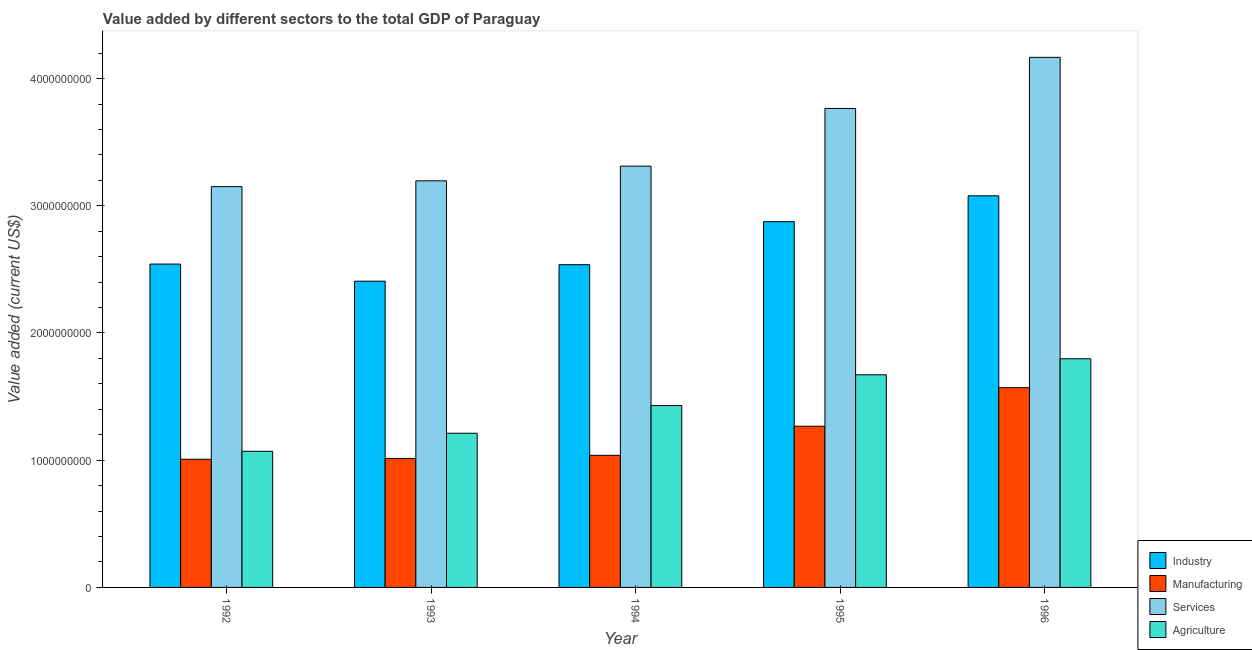How many different coloured bars are there?
Your answer should be compact. 4. How many groups of bars are there?
Make the answer very short. 5. Are the number of bars on each tick of the X-axis equal?
Give a very brief answer. Yes. How many bars are there on the 2nd tick from the left?
Make the answer very short. 4. How many bars are there on the 3rd tick from the right?
Keep it short and to the point. 4. What is the label of the 5th group of bars from the left?
Provide a short and direct response. 1996. What is the value added by services sector in 1995?
Make the answer very short. 3.77e+09. Across all years, what is the maximum value added by manufacturing sector?
Provide a succinct answer. 1.57e+09. Across all years, what is the minimum value added by services sector?
Offer a very short reply. 3.15e+09. In which year was the value added by industrial sector maximum?
Give a very brief answer. 1996. What is the total value added by services sector in the graph?
Offer a terse response. 1.76e+1. What is the difference between the value added by industrial sector in 1993 and that in 1996?
Offer a very short reply. -6.71e+08. What is the difference between the value added by agricultural sector in 1992 and the value added by services sector in 1996?
Ensure brevity in your answer.  -7.28e+08. What is the average value added by services sector per year?
Make the answer very short. 3.52e+09. In how many years, is the value added by manufacturing sector greater than 3000000000 US$?
Provide a short and direct response. 0. What is the ratio of the value added by services sector in 1994 to that in 1995?
Keep it short and to the point. 0.88. Is the difference between the value added by manufacturing sector in 1993 and 1994 greater than the difference between the value added by services sector in 1993 and 1994?
Make the answer very short. No. What is the difference between the highest and the second highest value added by industrial sector?
Your answer should be very brief. 2.03e+08. What is the difference between the highest and the lowest value added by manufacturing sector?
Your answer should be very brief. 5.63e+08. Is it the case that in every year, the sum of the value added by services sector and value added by agricultural sector is greater than the sum of value added by manufacturing sector and value added by industrial sector?
Provide a succinct answer. Yes. What does the 3rd bar from the left in 1994 represents?
Give a very brief answer. Services. What does the 1st bar from the right in 1995 represents?
Offer a very short reply. Agriculture. How many bars are there?
Ensure brevity in your answer.  20. How many years are there in the graph?
Your response must be concise. 5. Are the values on the major ticks of Y-axis written in scientific E-notation?
Ensure brevity in your answer.  No. Does the graph contain any zero values?
Your response must be concise. No. How many legend labels are there?
Your response must be concise. 4. How are the legend labels stacked?
Your response must be concise. Vertical. What is the title of the graph?
Give a very brief answer. Value added by different sectors to the total GDP of Paraguay. Does "Quality of logistic services" appear as one of the legend labels in the graph?
Offer a terse response. No. What is the label or title of the X-axis?
Offer a very short reply. Year. What is the label or title of the Y-axis?
Your response must be concise. Value added (current US$). What is the Value added (current US$) in Industry in 1992?
Make the answer very short. 2.54e+09. What is the Value added (current US$) of Manufacturing in 1992?
Your response must be concise. 1.01e+09. What is the Value added (current US$) in Services in 1992?
Offer a very short reply. 3.15e+09. What is the Value added (current US$) of Agriculture in 1992?
Your response must be concise. 1.07e+09. What is the Value added (current US$) of Industry in 1993?
Offer a terse response. 2.41e+09. What is the Value added (current US$) of Manufacturing in 1993?
Provide a short and direct response. 1.01e+09. What is the Value added (current US$) in Services in 1993?
Your answer should be very brief. 3.20e+09. What is the Value added (current US$) of Agriculture in 1993?
Ensure brevity in your answer.  1.21e+09. What is the Value added (current US$) of Industry in 1994?
Your answer should be compact. 2.54e+09. What is the Value added (current US$) of Manufacturing in 1994?
Give a very brief answer. 1.04e+09. What is the Value added (current US$) of Services in 1994?
Your answer should be compact. 3.31e+09. What is the Value added (current US$) in Agriculture in 1994?
Offer a terse response. 1.43e+09. What is the Value added (current US$) in Industry in 1995?
Provide a short and direct response. 2.88e+09. What is the Value added (current US$) of Manufacturing in 1995?
Ensure brevity in your answer.  1.27e+09. What is the Value added (current US$) in Services in 1995?
Keep it short and to the point. 3.77e+09. What is the Value added (current US$) of Agriculture in 1995?
Your answer should be very brief. 1.67e+09. What is the Value added (current US$) of Industry in 1996?
Make the answer very short. 3.08e+09. What is the Value added (current US$) of Manufacturing in 1996?
Make the answer very short. 1.57e+09. What is the Value added (current US$) in Services in 1996?
Provide a short and direct response. 4.17e+09. What is the Value added (current US$) in Agriculture in 1996?
Keep it short and to the point. 1.80e+09. Across all years, what is the maximum Value added (current US$) in Industry?
Offer a very short reply. 3.08e+09. Across all years, what is the maximum Value added (current US$) of Manufacturing?
Offer a very short reply. 1.57e+09. Across all years, what is the maximum Value added (current US$) of Services?
Provide a short and direct response. 4.17e+09. Across all years, what is the maximum Value added (current US$) in Agriculture?
Make the answer very short. 1.80e+09. Across all years, what is the minimum Value added (current US$) of Industry?
Offer a terse response. 2.41e+09. Across all years, what is the minimum Value added (current US$) in Manufacturing?
Your answer should be very brief. 1.01e+09. Across all years, what is the minimum Value added (current US$) in Services?
Offer a terse response. 3.15e+09. Across all years, what is the minimum Value added (current US$) in Agriculture?
Give a very brief answer. 1.07e+09. What is the total Value added (current US$) in Industry in the graph?
Offer a very short reply. 1.34e+1. What is the total Value added (current US$) of Manufacturing in the graph?
Make the answer very short. 5.90e+09. What is the total Value added (current US$) of Services in the graph?
Your answer should be compact. 1.76e+1. What is the total Value added (current US$) of Agriculture in the graph?
Provide a short and direct response. 7.18e+09. What is the difference between the Value added (current US$) of Industry in 1992 and that in 1993?
Offer a terse response. 1.34e+08. What is the difference between the Value added (current US$) in Manufacturing in 1992 and that in 1993?
Offer a terse response. -6.48e+06. What is the difference between the Value added (current US$) of Services in 1992 and that in 1993?
Ensure brevity in your answer.  -4.55e+07. What is the difference between the Value added (current US$) of Agriculture in 1992 and that in 1993?
Your answer should be compact. -1.42e+08. What is the difference between the Value added (current US$) in Industry in 1992 and that in 1994?
Your answer should be compact. 4.75e+06. What is the difference between the Value added (current US$) of Manufacturing in 1992 and that in 1994?
Your answer should be very brief. -3.08e+07. What is the difference between the Value added (current US$) in Services in 1992 and that in 1994?
Make the answer very short. -1.61e+08. What is the difference between the Value added (current US$) in Agriculture in 1992 and that in 1994?
Make the answer very short. -3.60e+08. What is the difference between the Value added (current US$) of Industry in 1992 and that in 1995?
Offer a very short reply. -3.33e+08. What is the difference between the Value added (current US$) of Manufacturing in 1992 and that in 1995?
Keep it short and to the point. -2.60e+08. What is the difference between the Value added (current US$) of Services in 1992 and that in 1995?
Your answer should be compact. -6.15e+08. What is the difference between the Value added (current US$) of Agriculture in 1992 and that in 1995?
Offer a very short reply. -6.01e+08. What is the difference between the Value added (current US$) in Industry in 1992 and that in 1996?
Offer a terse response. -5.37e+08. What is the difference between the Value added (current US$) in Manufacturing in 1992 and that in 1996?
Ensure brevity in your answer.  -5.63e+08. What is the difference between the Value added (current US$) of Services in 1992 and that in 1996?
Your answer should be compact. -1.02e+09. What is the difference between the Value added (current US$) in Agriculture in 1992 and that in 1996?
Provide a succinct answer. -7.28e+08. What is the difference between the Value added (current US$) in Industry in 1993 and that in 1994?
Offer a very short reply. -1.30e+08. What is the difference between the Value added (current US$) of Manufacturing in 1993 and that in 1994?
Offer a very short reply. -2.43e+07. What is the difference between the Value added (current US$) in Services in 1993 and that in 1994?
Your response must be concise. -1.15e+08. What is the difference between the Value added (current US$) of Agriculture in 1993 and that in 1994?
Offer a very short reply. -2.18e+08. What is the difference between the Value added (current US$) of Industry in 1993 and that in 1995?
Your answer should be compact. -4.68e+08. What is the difference between the Value added (current US$) of Manufacturing in 1993 and that in 1995?
Your answer should be compact. -2.53e+08. What is the difference between the Value added (current US$) in Services in 1993 and that in 1995?
Offer a terse response. -5.69e+08. What is the difference between the Value added (current US$) of Agriculture in 1993 and that in 1995?
Provide a short and direct response. -4.59e+08. What is the difference between the Value added (current US$) of Industry in 1993 and that in 1996?
Your answer should be compact. -6.71e+08. What is the difference between the Value added (current US$) of Manufacturing in 1993 and that in 1996?
Give a very brief answer. -5.56e+08. What is the difference between the Value added (current US$) of Services in 1993 and that in 1996?
Offer a terse response. -9.71e+08. What is the difference between the Value added (current US$) of Agriculture in 1993 and that in 1996?
Keep it short and to the point. -5.86e+08. What is the difference between the Value added (current US$) in Industry in 1994 and that in 1995?
Keep it short and to the point. -3.38e+08. What is the difference between the Value added (current US$) in Manufacturing in 1994 and that in 1995?
Ensure brevity in your answer.  -2.29e+08. What is the difference between the Value added (current US$) of Services in 1994 and that in 1995?
Your answer should be compact. -4.54e+08. What is the difference between the Value added (current US$) of Agriculture in 1994 and that in 1995?
Give a very brief answer. -2.42e+08. What is the difference between the Value added (current US$) of Industry in 1994 and that in 1996?
Give a very brief answer. -5.41e+08. What is the difference between the Value added (current US$) of Manufacturing in 1994 and that in 1996?
Your answer should be compact. -5.32e+08. What is the difference between the Value added (current US$) in Services in 1994 and that in 1996?
Your response must be concise. -8.55e+08. What is the difference between the Value added (current US$) in Agriculture in 1994 and that in 1996?
Offer a very short reply. -3.68e+08. What is the difference between the Value added (current US$) in Industry in 1995 and that in 1996?
Offer a terse response. -2.03e+08. What is the difference between the Value added (current US$) of Manufacturing in 1995 and that in 1996?
Your answer should be very brief. -3.03e+08. What is the difference between the Value added (current US$) of Services in 1995 and that in 1996?
Ensure brevity in your answer.  -4.02e+08. What is the difference between the Value added (current US$) of Agriculture in 1995 and that in 1996?
Offer a very short reply. -1.26e+08. What is the difference between the Value added (current US$) in Industry in 1992 and the Value added (current US$) in Manufacturing in 1993?
Your response must be concise. 1.53e+09. What is the difference between the Value added (current US$) of Industry in 1992 and the Value added (current US$) of Services in 1993?
Make the answer very short. -6.54e+08. What is the difference between the Value added (current US$) in Industry in 1992 and the Value added (current US$) in Agriculture in 1993?
Provide a succinct answer. 1.33e+09. What is the difference between the Value added (current US$) of Manufacturing in 1992 and the Value added (current US$) of Services in 1993?
Keep it short and to the point. -2.19e+09. What is the difference between the Value added (current US$) in Manufacturing in 1992 and the Value added (current US$) in Agriculture in 1993?
Give a very brief answer. -2.05e+08. What is the difference between the Value added (current US$) of Services in 1992 and the Value added (current US$) of Agriculture in 1993?
Provide a short and direct response. 1.94e+09. What is the difference between the Value added (current US$) in Industry in 1992 and the Value added (current US$) in Manufacturing in 1994?
Your response must be concise. 1.50e+09. What is the difference between the Value added (current US$) of Industry in 1992 and the Value added (current US$) of Services in 1994?
Your response must be concise. -7.70e+08. What is the difference between the Value added (current US$) in Industry in 1992 and the Value added (current US$) in Agriculture in 1994?
Offer a terse response. 1.11e+09. What is the difference between the Value added (current US$) of Manufacturing in 1992 and the Value added (current US$) of Services in 1994?
Provide a short and direct response. -2.30e+09. What is the difference between the Value added (current US$) in Manufacturing in 1992 and the Value added (current US$) in Agriculture in 1994?
Provide a short and direct response. -4.22e+08. What is the difference between the Value added (current US$) of Services in 1992 and the Value added (current US$) of Agriculture in 1994?
Make the answer very short. 1.72e+09. What is the difference between the Value added (current US$) in Industry in 1992 and the Value added (current US$) in Manufacturing in 1995?
Your response must be concise. 1.27e+09. What is the difference between the Value added (current US$) in Industry in 1992 and the Value added (current US$) in Services in 1995?
Your answer should be very brief. -1.22e+09. What is the difference between the Value added (current US$) of Industry in 1992 and the Value added (current US$) of Agriculture in 1995?
Give a very brief answer. 8.70e+08. What is the difference between the Value added (current US$) of Manufacturing in 1992 and the Value added (current US$) of Services in 1995?
Offer a very short reply. -2.76e+09. What is the difference between the Value added (current US$) in Manufacturing in 1992 and the Value added (current US$) in Agriculture in 1995?
Offer a very short reply. -6.64e+08. What is the difference between the Value added (current US$) of Services in 1992 and the Value added (current US$) of Agriculture in 1995?
Your answer should be very brief. 1.48e+09. What is the difference between the Value added (current US$) in Industry in 1992 and the Value added (current US$) in Manufacturing in 1996?
Provide a short and direct response. 9.72e+08. What is the difference between the Value added (current US$) in Industry in 1992 and the Value added (current US$) in Services in 1996?
Offer a terse response. -1.63e+09. What is the difference between the Value added (current US$) of Industry in 1992 and the Value added (current US$) of Agriculture in 1996?
Ensure brevity in your answer.  7.44e+08. What is the difference between the Value added (current US$) of Manufacturing in 1992 and the Value added (current US$) of Services in 1996?
Offer a terse response. -3.16e+09. What is the difference between the Value added (current US$) in Manufacturing in 1992 and the Value added (current US$) in Agriculture in 1996?
Make the answer very short. -7.90e+08. What is the difference between the Value added (current US$) in Services in 1992 and the Value added (current US$) in Agriculture in 1996?
Provide a short and direct response. 1.35e+09. What is the difference between the Value added (current US$) in Industry in 1993 and the Value added (current US$) in Manufacturing in 1994?
Provide a succinct answer. 1.37e+09. What is the difference between the Value added (current US$) of Industry in 1993 and the Value added (current US$) of Services in 1994?
Give a very brief answer. -9.04e+08. What is the difference between the Value added (current US$) in Industry in 1993 and the Value added (current US$) in Agriculture in 1994?
Your answer should be very brief. 9.77e+08. What is the difference between the Value added (current US$) in Manufacturing in 1993 and the Value added (current US$) in Services in 1994?
Your answer should be compact. -2.30e+09. What is the difference between the Value added (current US$) of Manufacturing in 1993 and the Value added (current US$) of Agriculture in 1994?
Offer a very short reply. -4.16e+08. What is the difference between the Value added (current US$) of Services in 1993 and the Value added (current US$) of Agriculture in 1994?
Your answer should be very brief. 1.77e+09. What is the difference between the Value added (current US$) of Industry in 1993 and the Value added (current US$) of Manufacturing in 1995?
Ensure brevity in your answer.  1.14e+09. What is the difference between the Value added (current US$) of Industry in 1993 and the Value added (current US$) of Services in 1995?
Offer a very short reply. -1.36e+09. What is the difference between the Value added (current US$) in Industry in 1993 and the Value added (current US$) in Agriculture in 1995?
Provide a succinct answer. 7.36e+08. What is the difference between the Value added (current US$) in Manufacturing in 1993 and the Value added (current US$) in Services in 1995?
Provide a short and direct response. -2.75e+09. What is the difference between the Value added (current US$) in Manufacturing in 1993 and the Value added (current US$) in Agriculture in 1995?
Give a very brief answer. -6.57e+08. What is the difference between the Value added (current US$) in Services in 1993 and the Value added (current US$) in Agriculture in 1995?
Offer a terse response. 1.52e+09. What is the difference between the Value added (current US$) in Industry in 1993 and the Value added (current US$) in Manufacturing in 1996?
Offer a very short reply. 8.37e+08. What is the difference between the Value added (current US$) in Industry in 1993 and the Value added (current US$) in Services in 1996?
Ensure brevity in your answer.  -1.76e+09. What is the difference between the Value added (current US$) of Industry in 1993 and the Value added (current US$) of Agriculture in 1996?
Keep it short and to the point. 6.10e+08. What is the difference between the Value added (current US$) of Manufacturing in 1993 and the Value added (current US$) of Services in 1996?
Your response must be concise. -3.15e+09. What is the difference between the Value added (current US$) of Manufacturing in 1993 and the Value added (current US$) of Agriculture in 1996?
Provide a succinct answer. -7.84e+08. What is the difference between the Value added (current US$) of Services in 1993 and the Value added (current US$) of Agriculture in 1996?
Give a very brief answer. 1.40e+09. What is the difference between the Value added (current US$) of Industry in 1994 and the Value added (current US$) of Manufacturing in 1995?
Your answer should be very brief. 1.27e+09. What is the difference between the Value added (current US$) in Industry in 1994 and the Value added (current US$) in Services in 1995?
Give a very brief answer. -1.23e+09. What is the difference between the Value added (current US$) of Industry in 1994 and the Value added (current US$) of Agriculture in 1995?
Keep it short and to the point. 8.66e+08. What is the difference between the Value added (current US$) in Manufacturing in 1994 and the Value added (current US$) in Services in 1995?
Provide a short and direct response. -2.73e+09. What is the difference between the Value added (current US$) of Manufacturing in 1994 and the Value added (current US$) of Agriculture in 1995?
Your answer should be very brief. -6.33e+08. What is the difference between the Value added (current US$) in Services in 1994 and the Value added (current US$) in Agriculture in 1995?
Make the answer very short. 1.64e+09. What is the difference between the Value added (current US$) in Industry in 1994 and the Value added (current US$) in Manufacturing in 1996?
Your answer should be compact. 9.67e+08. What is the difference between the Value added (current US$) of Industry in 1994 and the Value added (current US$) of Services in 1996?
Your answer should be very brief. -1.63e+09. What is the difference between the Value added (current US$) of Industry in 1994 and the Value added (current US$) of Agriculture in 1996?
Your answer should be very brief. 7.39e+08. What is the difference between the Value added (current US$) of Manufacturing in 1994 and the Value added (current US$) of Services in 1996?
Keep it short and to the point. -3.13e+09. What is the difference between the Value added (current US$) in Manufacturing in 1994 and the Value added (current US$) in Agriculture in 1996?
Provide a short and direct response. -7.59e+08. What is the difference between the Value added (current US$) of Services in 1994 and the Value added (current US$) of Agriculture in 1996?
Make the answer very short. 1.51e+09. What is the difference between the Value added (current US$) of Industry in 1995 and the Value added (current US$) of Manufacturing in 1996?
Keep it short and to the point. 1.31e+09. What is the difference between the Value added (current US$) in Industry in 1995 and the Value added (current US$) in Services in 1996?
Keep it short and to the point. -1.29e+09. What is the difference between the Value added (current US$) of Industry in 1995 and the Value added (current US$) of Agriculture in 1996?
Provide a short and direct response. 1.08e+09. What is the difference between the Value added (current US$) of Manufacturing in 1995 and the Value added (current US$) of Services in 1996?
Offer a very short reply. -2.90e+09. What is the difference between the Value added (current US$) of Manufacturing in 1995 and the Value added (current US$) of Agriculture in 1996?
Keep it short and to the point. -5.30e+08. What is the difference between the Value added (current US$) in Services in 1995 and the Value added (current US$) in Agriculture in 1996?
Provide a succinct answer. 1.97e+09. What is the average Value added (current US$) of Industry per year?
Give a very brief answer. 2.69e+09. What is the average Value added (current US$) in Manufacturing per year?
Give a very brief answer. 1.18e+09. What is the average Value added (current US$) in Services per year?
Provide a succinct answer. 3.52e+09. What is the average Value added (current US$) of Agriculture per year?
Your answer should be very brief. 1.44e+09. In the year 1992, what is the difference between the Value added (current US$) of Industry and Value added (current US$) of Manufacturing?
Your response must be concise. 1.53e+09. In the year 1992, what is the difference between the Value added (current US$) in Industry and Value added (current US$) in Services?
Your answer should be very brief. -6.09e+08. In the year 1992, what is the difference between the Value added (current US$) in Industry and Value added (current US$) in Agriculture?
Ensure brevity in your answer.  1.47e+09. In the year 1992, what is the difference between the Value added (current US$) in Manufacturing and Value added (current US$) in Services?
Offer a very short reply. -2.14e+09. In the year 1992, what is the difference between the Value added (current US$) of Manufacturing and Value added (current US$) of Agriculture?
Provide a short and direct response. -6.24e+07. In the year 1992, what is the difference between the Value added (current US$) in Services and Value added (current US$) in Agriculture?
Offer a terse response. 2.08e+09. In the year 1993, what is the difference between the Value added (current US$) of Industry and Value added (current US$) of Manufacturing?
Offer a terse response. 1.39e+09. In the year 1993, what is the difference between the Value added (current US$) of Industry and Value added (current US$) of Services?
Ensure brevity in your answer.  -7.89e+08. In the year 1993, what is the difference between the Value added (current US$) of Industry and Value added (current US$) of Agriculture?
Offer a very short reply. 1.20e+09. In the year 1993, what is the difference between the Value added (current US$) in Manufacturing and Value added (current US$) in Services?
Your answer should be compact. -2.18e+09. In the year 1993, what is the difference between the Value added (current US$) in Manufacturing and Value added (current US$) in Agriculture?
Give a very brief answer. -1.98e+08. In the year 1993, what is the difference between the Value added (current US$) in Services and Value added (current US$) in Agriculture?
Offer a terse response. 1.98e+09. In the year 1994, what is the difference between the Value added (current US$) of Industry and Value added (current US$) of Manufacturing?
Ensure brevity in your answer.  1.50e+09. In the year 1994, what is the difference between the Value added (current US$) in Industry and Value added (current US$) in Services?
Keep it short and to the point. -7.75e+08. In the year 1994, what is the difference between the Value added (current US$) of Industry and Value added (current US$) of Agriculture?
Offer a very short reply. 1.11e+09. In the year 1994, what is the difference between the Value added (current US$) in Manufacturing and Value added (current US$) in Services?
Keep it short and to the point. -2.27e+09. In the year 1994, what is the difference between the Value added (current US$) in Manufacturing and Value added (current US$) in Agriculture?
Provide a short and direct response. -3.91e+08. In the year 1994, what is the difference between the Value added (current US$) in Services and Value added (current US$) in Agriculture?
Make the answer very short. 1.88e+09. In the year 1995, what is the difference between the Value added (current US$) of Industry and Value added (current US$) of Manufacturing?
Make the answer very short. 1.61e+09. In the year 1995, what is the difference between the Value added (current US$) of Industry and Value added (current US$) of Services?
Your response must be concise. -8.90e+08. In the year 1995, what is the difference between the Value added (current US$) in Industry and Value added (current US$) in Agriculture?
Ensure brevity in your answer.  1.20e+09. In the year 1995, what is the difference between the Value added (current US$) of Manufacturing and Value added (current US$) of Services?
Offer a terse response. -2.50e+09. In the year 1995, what is the difference between the Value added (current US$) of Manufacturing and Value added (current US$) of Agriculture?
Your answer should be compact. -4.04e+08. In the year 1995, what is the difference between the Value added (current US$) in Services and Value added (current US$) in Agriculture?
Ensure brevity in your answer.  2.09e+09. In the year 1996, what is the difference between the Value added (current US$) of Industry and Value added (current US$) of Manufacturing?
Ensure brevity in your answer.  1.51e+09. In the year 1996, what is the difference between the Value added (current US$) in Industry and Value added (current US$) in Services?
Offer a terse response. -1.09e+09. In the year 1996, what is the difference between the Value added (current US$) of Industry and Value added (current US$) of Agriculture?
Your answer should be very brief. 1.28e+09. In the year 1996, what is the difference between the Value added (current US$) in Manufacturing and Value added (current US$) in Services?
Provide a succinct answer. -2.60e+09. In the year 1996, what is the difference between the Value added (current US$) in Manufacturing and Value added (current US$) in Agriculture?
Keep it short and to the point. -2.28e+08. In the year 1996, what is the difference between the Value added (current US$) of Services and Value added (current US$) of Agriculture?
Offer a very short reply. 2.37e+09. What is the ratio of the Value added (current US$) of Industry in 1992 to that in 1993?
Offer a very short reply. 1.06. What is the ratio of the Value added (current US$) in Manufacturing in 1992 to that in 1993?
Your answer should be very brief. 0.99. What is the ratio of the Value added (current US$) in Services in 1992 to that in 1993?
Provide a short and direct response. 0.99. What is the ratio of the Value added (current US$) of Agriculture in 1992 to that in 1993?
Your answer should be compact. 0.88. What is the ratio of the Value added (current US$) of Industry in 1992 to that in 1994?
Offer a terse response. 1. What is the ratio of the Value added (current US$) of Manufacturing in 1992 to that in 1994?
Make the answer very short. 0.97. What is the ratio of the Value added (current US$) of Services in 1992 to that in 1994?
Your answer should be compact. 0.95. What is the ratio of the Value added (current US$) in Agriculture in 1992 to that in 1994?
Keep it short and to the point. 0.75. What is the ratio of the Value added (current US$) of Industry in 1992 to that in 1995?
Ensure brevity in your answer.  0.88. What is the ratio of the Value added (current US$) in Manufacturing in 1992 to that in 1995?
Make the answer very short. 0.8. What is the ratio of the Value added (current US$) in Services in 1992 to that in 1995?
Make the answer very short. 0.84. What is the ratio of the Value added (current US$) in Agriculture in 1992 to that in 1995?
Offer a terse response. 0.64. What is the ratio of the Value added (current US$) of Industry in 1992 to that in 1996?
Make the answer very short. 0.83. What is the ratio of the Value added (current US$) in Manufacturing in 1992 to that in 1996?
Give a very brief answer. 0.64. What is the ratio of the Value added (current US$) in Services in 1992 to that in 1996?
Keep it short and to the point. 0.76. What is the ratio of the Value added (current US$) of Agriculture in 1992 to that in 1996?
Your response must be concise. 0.6. What is the ratio of the Value added (current US$) of Industry in 1993 to that in 1994?
Provide a short and direct response. 0.95. What is the ratio of the Value added (current US$) in Manufacturing in 1993 to that in 1994?
Provide a short and direct response. 0.98. What is the ratio of the Value added (current US$) in Services in 1993 to that in 1994?
Keep it short and to the point. 0.97. What is the ratio of the Value added (current US$) in Agriculture in 1993 to that in 1994?
Your answer should be compact. 0.85. What is the ratio of the Value added (current US$) of Industry in 1993 to that in 1995?
Your answer should be very brief. 0.84. What is the ratio of the Value added (current US$) of Manufacturing in 1993 to that in 1995?
Keep it short and to the point. 0.8. What is the ratio of the Value added (current US$) in Services in 1993 to that in 1995?
Offer a terse response. 0.85. What is the ratio of the Value added (current US$) of Agriculture in 1993 to that in 1995?
Make the answer very short. 0.73. What is the ratio of the Value added (current US$) of Industry in 1993 to that in 1996?
Provide a short and direct response. 0.78. What is the ratio of the Value added (current US$) in Manufacturing in 1993 to that in 1996?
Give a very brief answer. 0.65. What is the ratio of the Value added (current US$) in Services in 1993 to that in 1996?
Provide a short and direct response. 0.77. What is the ratio of the Value added (current US$) in Agriculture in 1993 to that in 1996?
Offer a very short reply. 0.67. What is the ratio of the Value added (current US$) of Industry in 1994 to that in 1995?
Offer a very short reply. 0.88. What is the ratio of the Value added (current US$) of Manufacturing in 1994 to that in 1995?
Ensure brevity in your answer.  0.82. What is the ratio of the Value added (current US$) in Services in 1994 to that in 1995?
Offer a terse response. 0.88. What is the ratio of the Value added (current US$) in Agriculture in 1994 to that in 1995?
Provide a succinct answer. 0.86. What is the ratio of the Value added (current US$) in Industry in 1994 to that in 1996?
Ensure brevity in your answer.  0.82. What is the ratio of the Value added (current US$) of Manufacturing in 1994 to that in 1996?
Give a very brief answer. 0.66. What is the ratio of the Value added (current US$) in Services in 1994 to that in 1996?
Provide a succinct answer. 0.79. What is the ratio of the Value added (current US$) of Agriculture in 1994 to that in 1996?
Make the answer very short. 0.8. What is the ratio of the Value added (current US$) in Industry in 1995 to that in 1996?
Give a very brief answer. 0.93. What is the ratio of the Value added (current US$) in Manufacturing in 1995 to that in 1996?
Ensure brevity in your answer.  0.81. What is the ratio of the Value added (current US$) in Services in 1995 to that in 1996?
Provide a short and direct response. 0.9. What is the ratio of the Value added (current US$) in Agriculture in 1995 to that in 1996?
Your response must be concise. 0.93. What is the difference between the highest and the second highest Value added (current US$) in Industry?
Keep it short and to the point. 2.03e+08. What is the difference between the highest and the second highest Value added (current US$) of Manufacturing?
Provide a short and direct response. 3.03e+08. What is the difference between the highest and the second highest Value added (current US$) of Services?
Offer a terse response. 4.02e+08. What is the difference between the highest and the second highest Value added (current US$) of Agriculture?
Provide a succinct answer. 1.26e+08. What is the difference between the highest and the lowest Value added (current US$) in Industry?
Your response must be concise. 6.71e+08. What is the difference between the highest and the lowest Value added (current US$) of Manufacturing?
Your response must be concise. 5.63e+08. What is the difference between the highest and the lowest Value added (current US$) in Services?
Offer a terse response. 1.02e+09. What is the difference between the highest and the lowest Value added (current US$) in Agriculture?
Offer a terse response. 7.28e+08. 